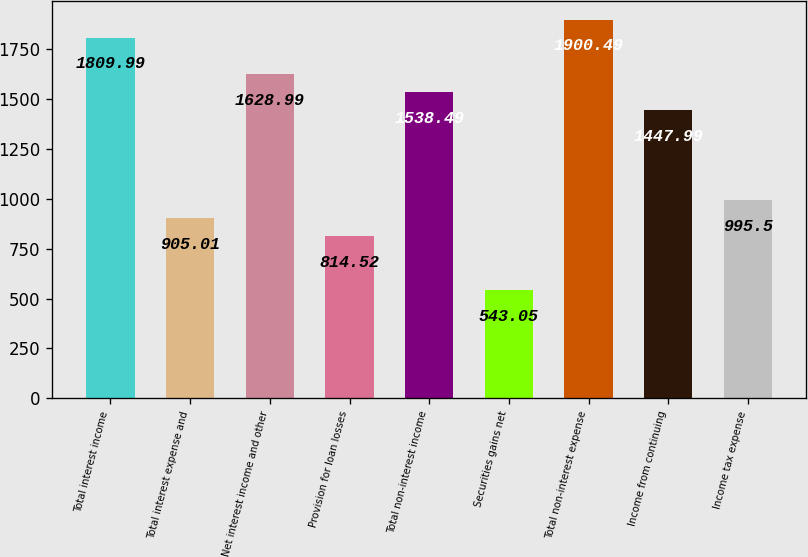Convert chart to OTSL. <chart><loc_0><loc_0><loc_500><loc_500><bar_chart><fcel>Total interest income<fcel>Total interest expense and<fcel>Net interest income and other<fcel>Provision for loan losses<fcel>Total non-interest income<fcel>Securities gains net<fcel>Total non-interest expense<fcel>Income from continuing<fcel>Income tax expense<nl><fcel>1809.99<fcel>905.01<fcel>1628.99<fcel>814.52<fcel>1538.49<fcel>543.05<fcel>1900.49<fcel>1447.99<fcel>995.5<nl></chart> 